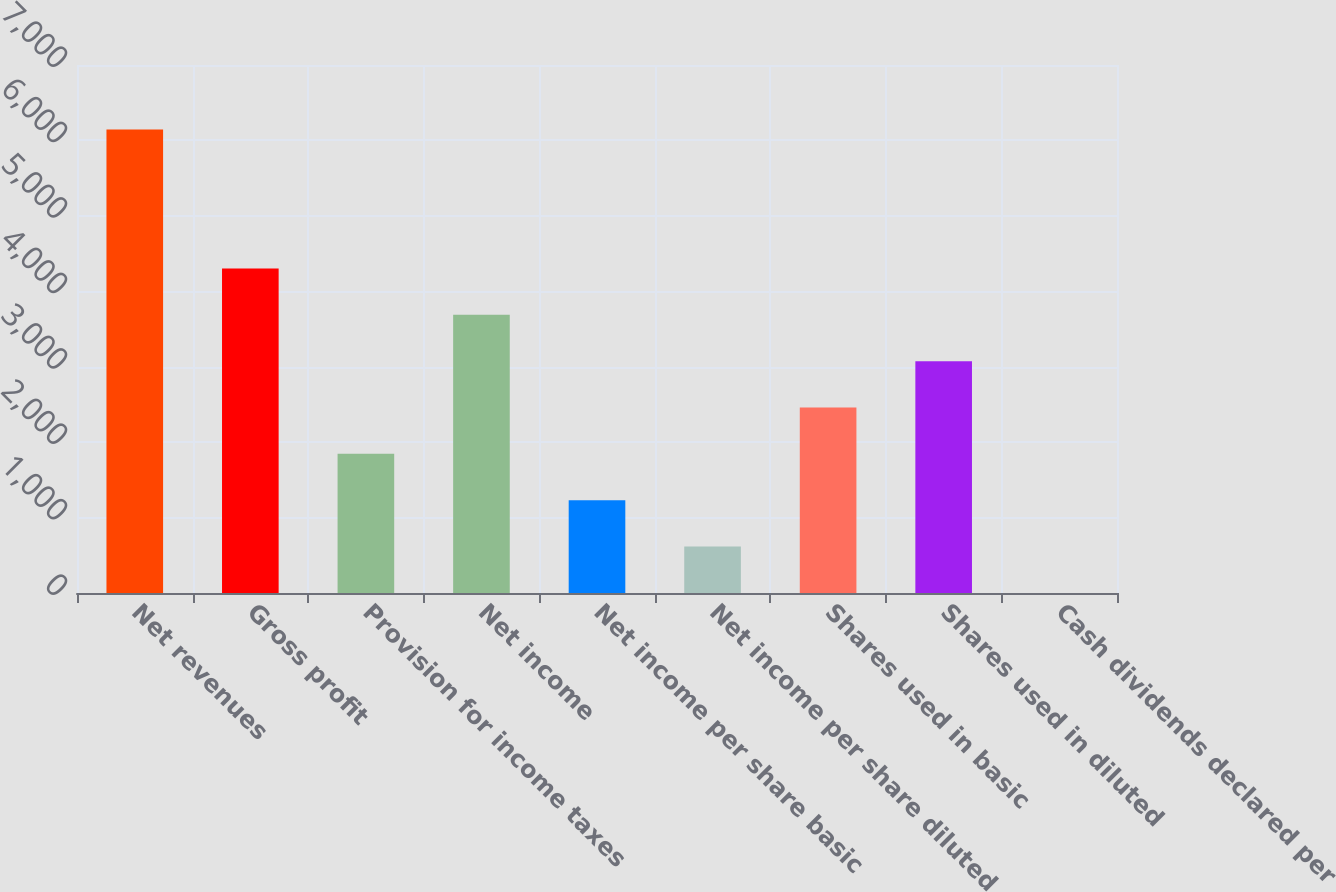Convert chart. <chart><loc_0><loc_0><loc_500><loc_500><bar_chart><fcel>Net revenues<fcel>Gross profit<fcel>Provision for income taxes<fcel>Net income<fcel>Net income per share basic<fcel>Net income per share diluted<fcel>Shares used in basic<fcel>Shares used in diluted<fcel>Cash dividends declared per<nl><fcel>6146<fcel>4302.68<fcel>1844.92<fcel>3688.24<fcel>1230.48<fcel>616.04<fcel>2459.36<fcel>3073.8<fcel>1.6<nl></chart> 